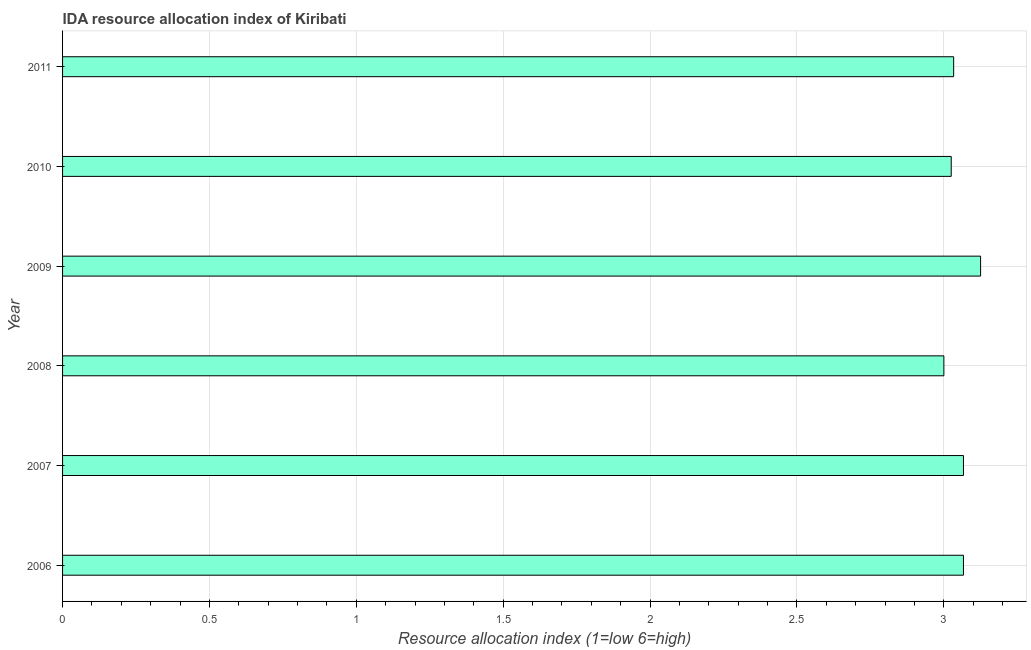Does the graph contain any zero values?
Offer a terse response. No. Does the graph contain grids?
Give a very brief answer. Yes. What is the title of the graph?
Offer a very short reply. IDA resource allocation index of Kiribati. What is the label or title of the X-axis?
Offer a very short reply. Resource allocation index (1=low 6=high). What is the ida resource allocation index in 2010?
Ensure brevity in your answer.  3.02. Across all years, what is the maximum ida resource allocation index?
Offer a very short reply. 3.12. Across all years, what is the minimum ida resource allocation index?
Make the answer very short. 3. In which year was the ida resource allocation index minimum?
Your answer should be compact. 2008. What is the sum of the ida resource allocation index?
Make the answer very short. 18.32. What is the difference between the ida resource allocation index in 2009 and 2011?
Make the answer very short. 0.09. What is the average ida resource allocation index per year?
Give a very brief answer. 3.05. What is the median ida resource allocation index?
Make the answer very short. 3.05. Is the ida resource allocation index in 2008 less than that in 2009?
Offer a terse response. Yes. What is the difference between the highest and the second highest ida resource allocation index?
Give a very brief answer. 0.06. What is the difference between the highest and the lowest ida resource allocation index?
Ensure brevity in your answer.  0.13. In how many years, is the ida resource allocation index greater than the average ida resource allocation index taken over all years?
Provide a succinct answer. 3. Are all the bars in the graph horizontal?
Offer a terse response. Yes. Are the values on the major ticks of X-axis written in scientific E-notation?
Offer a terse response. No. What is the Resource allocation index (1=low 6=high) of 2006?
Ensure brevity in your answer.  3.07. What is the Resource allocation index (1=low 6=high) of 2007?
Your answer should be very brief. 3.07. What is the Resource allocation index (1=low 6=high) of 2009?
Your response must be concise. 3.12. What is the Resource allocation index (1=low 6=high) in 2010?
Ensure brevity in your answer.  3.02. What is the Resource allocation index (1=low 6=high) of 2011?
Provide a short and direct response. 3.03. What is the difference between the Resource allocation index (1=low 6=high) in 2006 and 2008?
Ensure brevity in your answer.  0.07. What is the difference between the Resource allocation index (1=low 6=high) in 2006 and 2009?
Your answer should be very brief. -0.06. What is the difference between the Resource allocation index (1=low 6=high) in 2006 and 2010?
Keep it short and to the point. 0.04. What is the difference between the Resource allocation index (1=low 6=high) in 2006 and 2011?
Offer a very short reply. 0.03. What is the difference between the Resource allocation index (1=low 6=high) in 2007 and 2008?
Offer a terse response. 0.07. What is the difference between the Resource allocation index (1=low 6=high) in 2007 and 2009?
Offer a very short reply. -0.06. What is the difference between the Resource allocation index (1=low 6=high) in 2007 and 2010?
Ensure brevity in your answer.  0.04. What is the difference between the Resource allocation index (1=low 6=high) in 2007 and 2011?
Offer a terse response. 0.03. What is the difference between the Resource allocation index (1=low 6=high) in 2008 and 2009?
Your answer should be compact. -0.12. What is the difference between the Resource allocation index (1=low 6=high) in 2008 and 2010?
Offer a very short reply. -0.03. What is the difference between the Resource allocation index (1=low 6=high) in 2008 and 2011?
Ensure brevity in your answer.  -0.03. What is the difference between the Resource allocation index (1=low 6=high) in 2009 and 2011?
Offer a very short reply. 0.09. What is the difference between the Resource allocation index (1=low 6=high) in 2010 and 2011?
Give a very brief answer. -0.01. What is the ratio of the Resource allocation index (1=low 6=high) in 2006 to that in 2008?
Your response must be concise. 1.02. What is the ratio of the Resource allocation index (1=low 6=high) in 2006 to that in 2009?
Give a very brief answer. 0.98. What is the ratio of the Resource allocation index (1=low 6=high) in 2006 to that in 2010?
Offer a terse response. 1.01. What is the ratio of the Resource allocation index (1=low 6=high) in 2007 to that in 2009?
Offer a very short reply. 0.98. What is the ratio of the Resource allocation index (1=low 6=high) in 2007 to that in 2010?
Your response must be concise. 1.01. What is the ratio of the Resource allocation index (1=low 6=high) in 2007 to that in 2011?
Offer a very short reply. 1.01. What is the ratio of the Resource allocation index (1=low 6=high) in 2008 to that in 2009?
Provide a succinct answer. 0.96. What is the ratio of the Resource allocation index (1=low 6=high) in 2008 to that in 2010?
Provide a succinct answer. 0.99. What is the ratio of the Resource allocation index (1=low 6=high) in 2009 to that in 2010?
Provide a succinct answer. 1.03. What is the ratio of the Resource allocation index (1=low 6=high) in 2010 to that in 2011?
Provide a succinct answer. 1. 